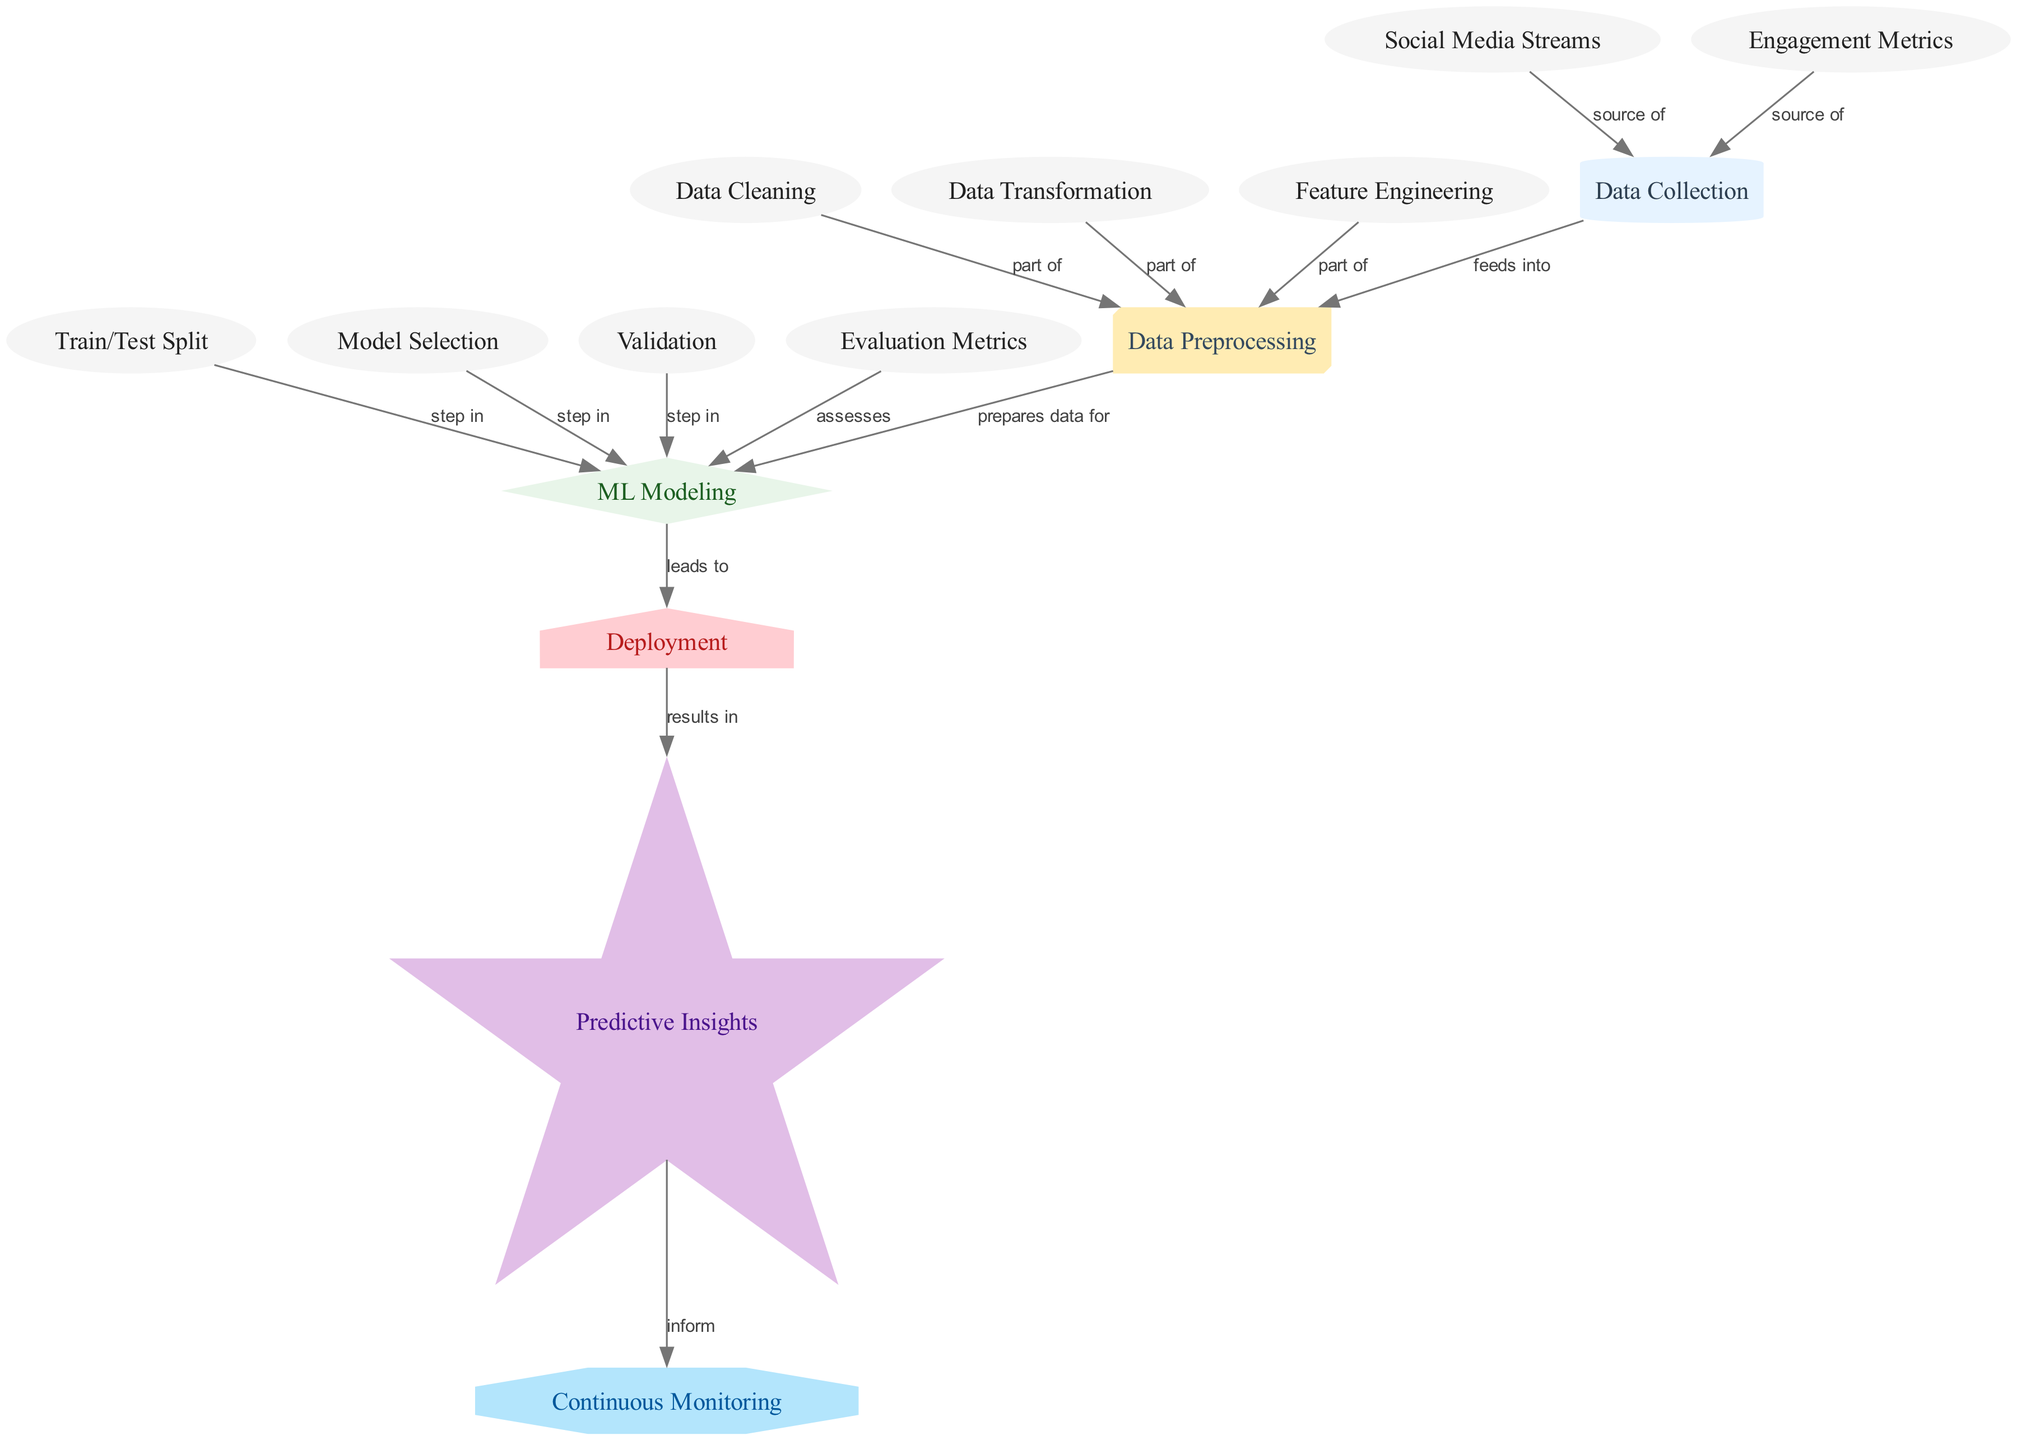What is the first step in the predictive analytics process? The diagram indicates that the first step is "Data Collection," as it is the initial node before any preprocessing or modeling occurs.
Answer: Data Collection How many nodes are present in the diagram? By counting all the unique nodes listed in the diagram, we find there are 15 nodes in total.
Answer: 15 Which node prepares data for machine learning modeling? The "Data Preprocessing" node directly follows "Data Collection" and is connected to "ML Modeling," indicating it prepares data for the modeling process.
Answer: Data Preprocessing What type of metrics assess ML modeling? The "Evaluation Metrics" node is indicated to assess the "ML Modeling," specifying that it measures the performance of the models produced.
Answer: Evaluation Metrics What are the three parts of data preprocessing? The diagram shows three nodes connected to "Data Preprocessing" - "Data Cleaning," "Data Transformation," and "Feature Engineering," which all contribute to preprocessing.
Answer: Data Cleaning, Data Transformation, Feature Engineering Which node results in predictive insights? The "Deployment" node leads to "Predictive Insights," indicating that deploying the model provides insights into predictions related to social media campaigns.
Answer: Predictive Insights How does continuous monitoring relate to predictive insights? "Continuous Monitoring" is informed by "Predictive Insights," showcasing that monitoring processes utilize insights generated from predictions.
Answer: Inform What step comes after model selection? "Validation" follows "Model Selection" as a step within the machine learning modeling process according to the directed edges in the diagram.
Answer: Validation What is the source of engagement metrics? "Engagement Metrics" is shown as a source of data that feeds into "Data Collection," essential for analyzing social media campaign performance.
Answer: Source of Engagement Metrics 